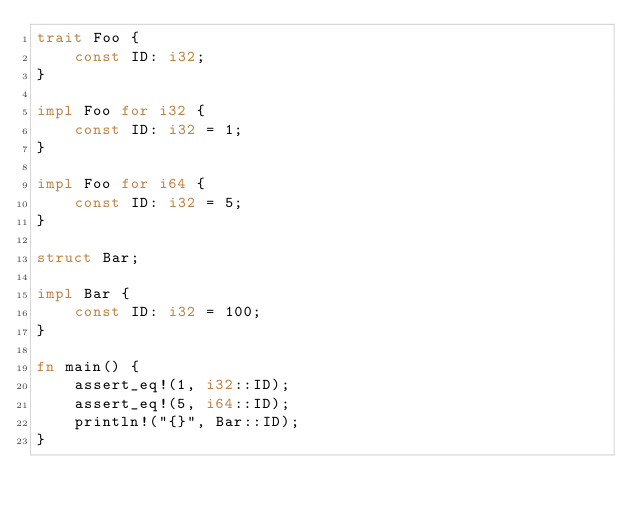<code> <loc_0><loc_0><loc_500><loc_500><_Rust_>trait Foo {
    const ID: i32;
}

impl Foo for i32 {
    const ID: i32 = 1;
}

impl Foo for i64 {
    const ID: i32 = 5;
}

struct Bar;

impl Bar {
    const ID: i32 = 100;
}

fn main() {
    assert_eq!(1, i32::ID);
    assert_eq!(5, i64::ID);
    println!("{}", Bar::ID);
}</code> 